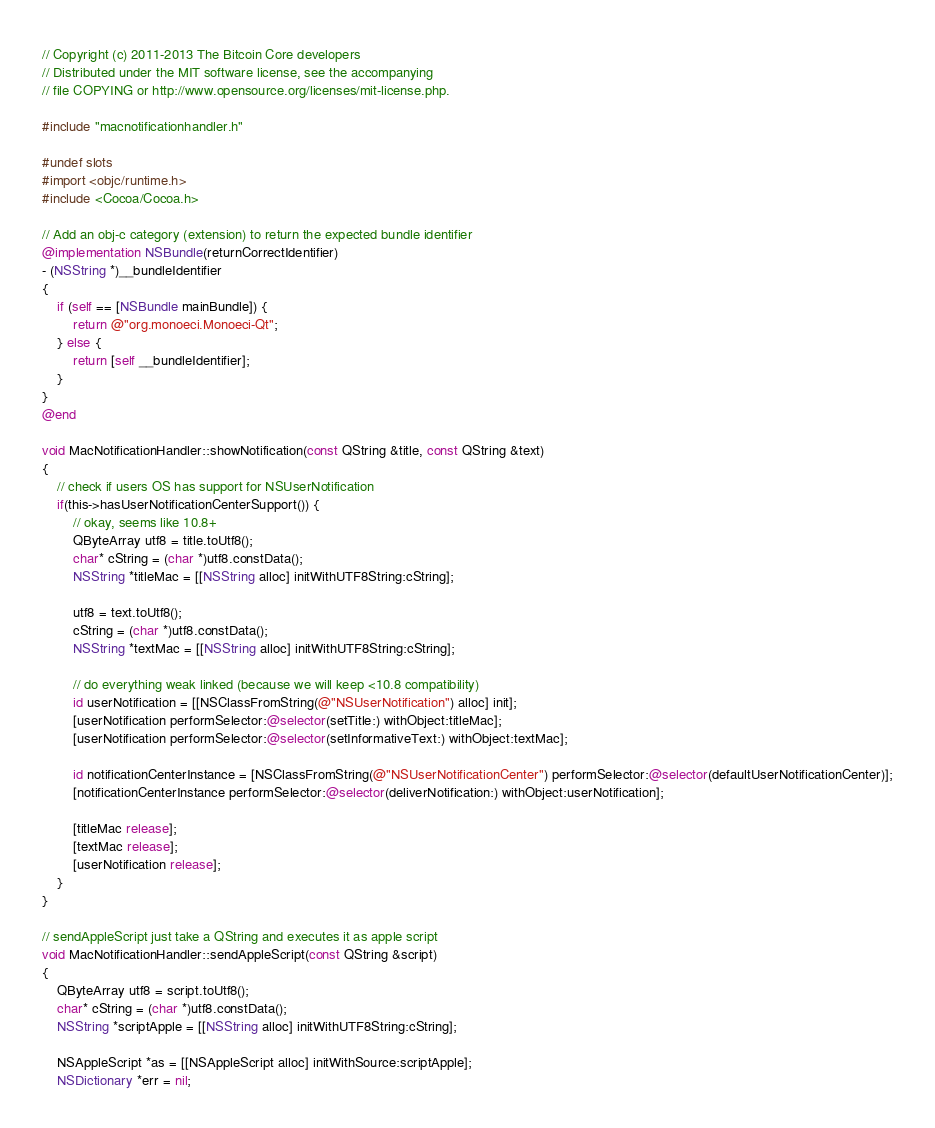Convert code to text. <code><loc_0><loc_0><loc_500><loc_500><_ObjectiveC_>// Copyright (c) 2011-2013 The Bitcoin Core developers
// Distributed under the MIT software license, see the accompanying
// file COPYING or http://www.opensource.org/licenses/mit-license.php.

#include "macnotificationhandler.h"

#undef slots
#import <objc/runtime.h>
#include <Cocoa/Cocoa.h>

// Add an obj-c category (extension) to return the expected bundle identifier
@implementation NSBundle(returnCorrectIdentifier)
- (NSString *)__bundleIdentifier
{
    if (self == [NSBundle mainBundle]) {
        return @"org.monoeci.Monoeci-Qt";
    } else {
        return [self __bundleIdentifier];
    }
}
@end

void MacNotificationHandler::showNotification(const QString &title, const QString &text)
{
    // check if users OS has support for NSUserNotification
    if(this->hasUserNotificationCenterSupport()) {
        // okay, seems like 10.8+
        QByteArray utf8 = title.toUtf8();
        char* cString = (char *)utf8.constData();
        NSString *titleMac = [[NSString alloc] initWithUTF8String:cString];

        utf8 = text.toUtf8();
        cString = (char *)utf8.constData();
        NSString *textMac = [[NSString alloc] initWithUTF8String:cString];

        // do everything weak linked (because we will keep <10.8 compatibility)
        id userNotification = [[NSClassFromString(@"NSUserNotification") alloc] init];
        [userNotification performSelector:@selector(setTitle:) withObject:titleMac];
        [userNotification performSelector:@selector(setInformativeText:) withObject:textMac];

        id notificationCenterInstance = [NSClassFromString(@"NSUserNotificationCenter") performSelector:@selector(defaultUserNotificationCenter)];
        [notificationCenterInstance performSelector:@selector(deliverNotification:) withObject:userNotification];

        [titleMac release];
        [textMac release];
        [userNotification release];
    }
}

// sendAppleScript just take a QString and executes it as apple script
void MacNotificationHandler::sendAppleScript(const QString &script)
{
    QByteArray utf8 = script.toUtf8();
    char* cString = (char *)utf8.constData();
    NSString *scriptApple = [[NSString alloc] initWithUTF8String:cString];

    NSAppleScript *as = [[NSAppleScript alloc] initWithSource:scriptApple];
    NSDictionary *err = nil;</code> 